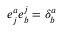Convert formula to latex. <formula><loc_0><loc_0><loc_500><loc_500>e _ { j } ^ { a } e _ { b } ^ { j } = \delta _ { b } ^ { a }</formula> 